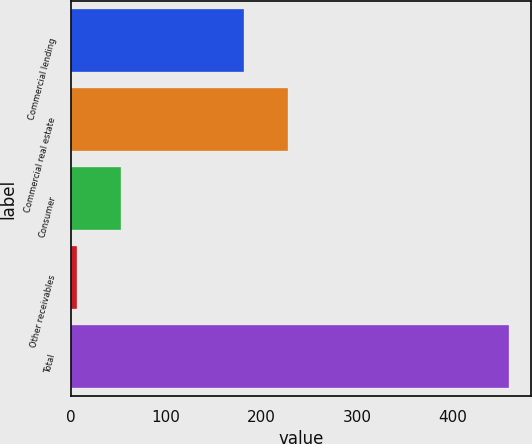<chart> <loc_0><loc_0><loc_500><loc_500><bar_chart><fcel>Commercial lending<fcel>Commercial real estate<fcel>Consumer<fcel>Other receivables<fcel>Total<nl><fcel>182<fcel>227.2<fcel>52.2<fcel>7<fcel>459<nl></chart> 